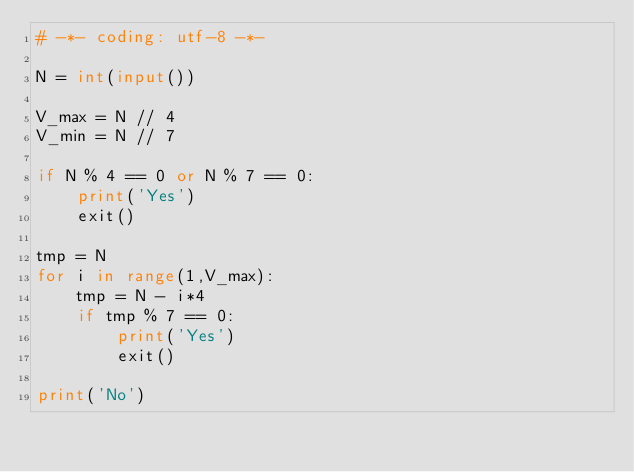<code> <loc_0><loc_0><loc_500><loc_500><_Python_># -*- coding: utf-8 -*-

N = int(input())

V_max = N // 4
V_min = N // 7

if N % 4 == 0 or N % 7 == 0:
    print('Yes')
    exit()

tmp = N
for i in range(1,V_max):
    tmp = N - i*4
    if tmp % 7 == 0:
        print('Yes')
        exit()

print('No')
</code> 